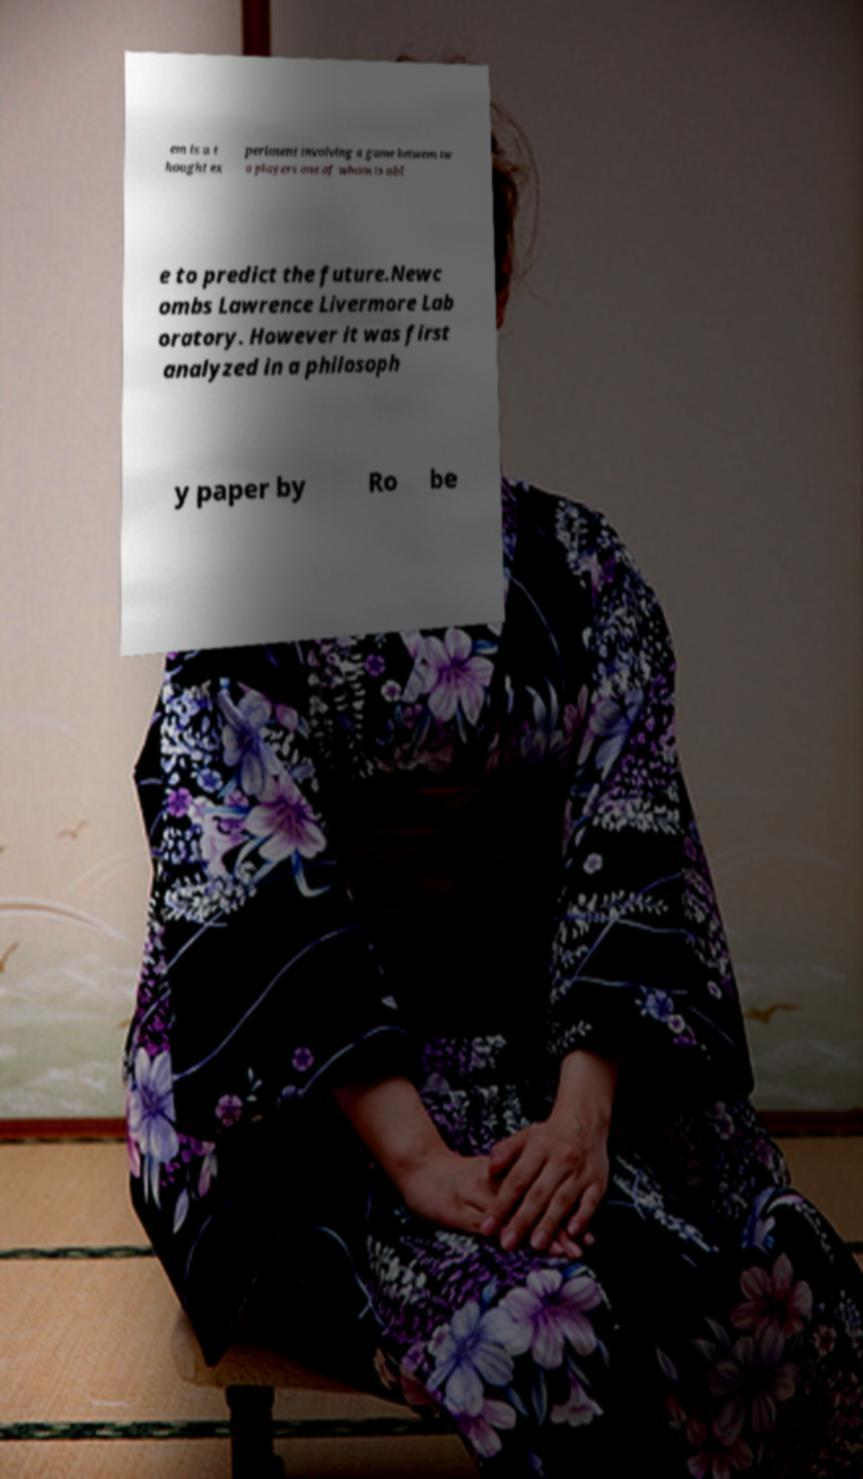What messages or text are displayed in this image? I need them in a readable, typed format. em is a t hought ex periment involving a game between tw o players one of whom is abl e to predict the future.Newc ombs Lawrence Livermore Lab oratory. However it was first analyzed in a philosoph y paper by Ro be 